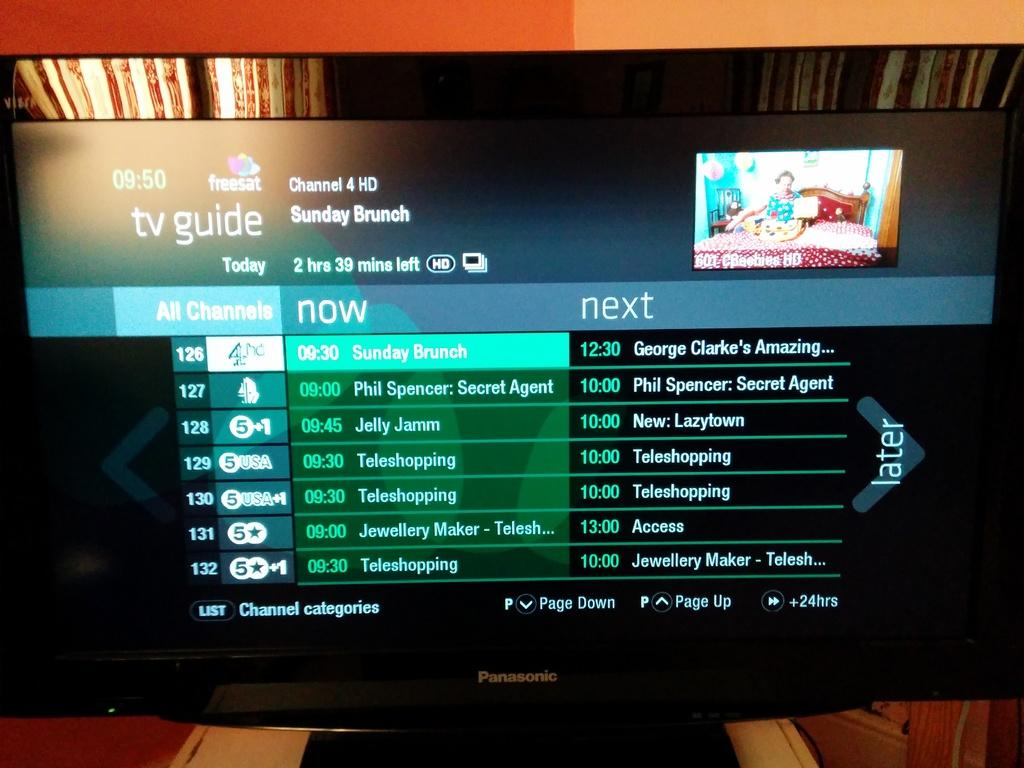<image>
Describe the image concisely. A television has the TV Guide pulled up on its screen. 